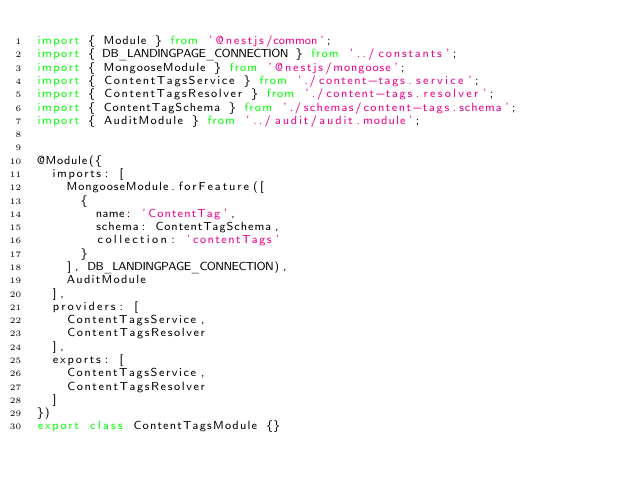Convert code to text. <code><loc_0><loc_0><loc_500><loc_500><_TypeScript_>import { Module } from '@nestjs/common';
import { DB_LANDINGPAGE_CONNECTION } from '../constants';
import { MongooseModule } from '@nestjs/mongoose';
import { ContentTagsService } from './content-tags.service';
import { ContentTagsResolver } from './content-tags.resolver';
import { ContentTagSchema } from './schemas/content-tags.schema';
import { AuditModule } from '../audit/audit.module';


@Module({
  imports: [
    MongooseModule.forFeature([
      {
        name: 'ContentTag',
        schema: ContentTagSchema,
        collection: 'contentTags'
      }
    ], DB_LANDINGPAGE_CONNECTION),
    AuditModule
  ],
  providers: [
    ContentTagsService,
    ContentTagsResolver
  ],
  exports: [
    ContentTagsService,
    ContentTagsResolver
  ]
})
export class ContentTagsModule {}
</code> 